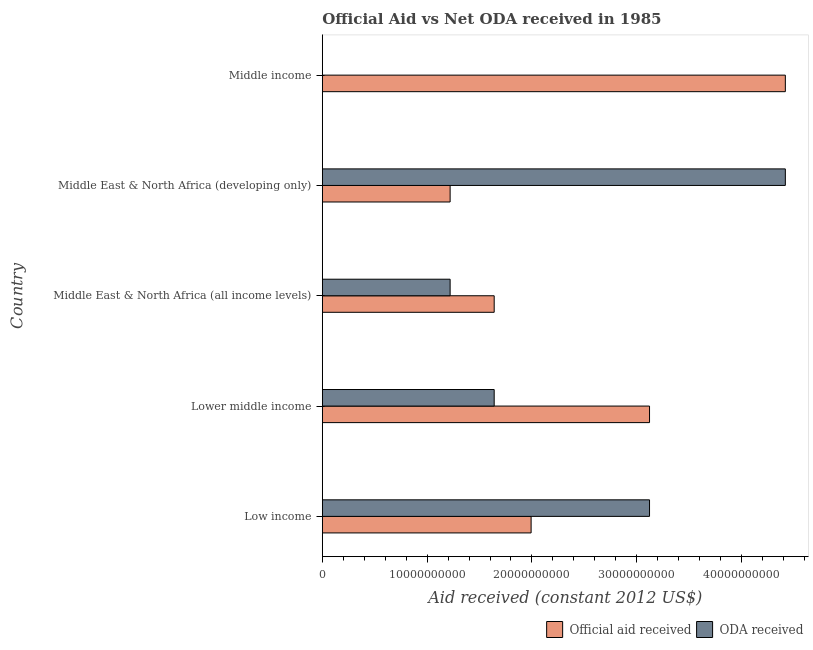How many groups of bars are there?
Offer a terse response. 5. Are the number of bars per tick equal to the number of legend labels?
Make the answer very short. Yes. Are the number of bars on each tick of the Y-axis equal?
Make the answer very short. Yes. What is the official aid received in Middle income?
Keep it short and to the point. 4.42e+1. Across all countries, what is the maximum oda received?
Give a very brief answer. 4.42e+1. Across all countries, what is the minimum oda received?
Make the answer very short. 3.02e+06. In which country was the oda received maximum?
Provide a short and direct response. Middle East & North Africa (developing only). What is the total official aid received in the graph?
Ensure brevity in your answer.  1.24e+11. What is the difference between the official aid received in Lower middle income and that in Middle East & North Africa (all income levels)?
Provide a succinct answer. 1.48e+1. What is the difference between the official aid received in Middle income and the oda received in Lower middle income?
Keep it short and to the point. 2.78e+1. What is the average official aid received per country?
Offer a very short reply. 2.48e+1. What is the difference between the official aid received and oda received in Middle East & North Africa (all income levels)?
Your answer should be compact. 4.20e+09. What is the ratio of the official aid received in Lower middle income to that in Middle East & North Africa (all income levels)?
Give a very brief answer. 1.9. Is the difference between the official aid received in Low income and Middle East & North Africa (all income levels) greater than the difference between the oda received in Low income and Middle East & North Africa (all income levels)?
Offer a terse response. No. What is the difference between the highest and the second highest oda received?
Make the answer very short. 1.30e+1. What is the difference between the highest and the lowest official aid received?
Ensure brevity in your answer.  3.20e+1. Is the sum of the oda received in Lower middle income and Middle income greater than the maximum official aid received across all countries?
Offer a very short reply. No. What does the 1st bar from the top in Middle East & North Africa (developing only) represents?
Provide a succinct answer. ODA received. What does the 1st bar from the bottom in Middle East & North Africa (developing only) represents?
Offer a terse response. Official aid received. What is the difference between two consecutive major ticks on the X-axis?
Your answer should be compact. 1.00e+1. How many legend labels are there?
Keep it short and to the point. 2. How are the legend labels stacked?
Your answer should be compact. Horizontal. What is the title of the graph?
Offer a very short reply. Official Aid vs Net ODA received in 1985 . Does "Exports" appear as one of the legend labels in the graph?
Give a very brief answer. No. What is the label or title of the X-axis?
Your answer should be very brief. Aid received (constant 2012 US$). What is the Aid received (constant 2012 US$) of Official aid received in Low income?
Your answer should be compact. 1.99e+1. What is the Aid received (constant 2012 US$) in ODA received in Low income?
Offer a very short reply. 3.12e+1. What is the Aid received (constant 2012 US$) of Official aid received in Lower middle income?
Your answer should be very brief. 3.12e+1. What is the Aid received (constant 2012 US$) in ODA received in Lower middle income?
Provide a short and direct response. 1.64e+1. What is the Aid received (constant 2012 US$) in Official aid received in Middle East & North Africa (all income levels)?
Your response must be concise. 1.64e+1. What is the Aid received (constant 2012 US$) of ODA received in Middle East & North Africa (all income levels)?
Your answer should be compact. 1.22e+1. What is the Aid received (constant 2012 US$) in Official aid received in Middle East & North Africa (developing only)?
Keep it short and to the point. 1.22e+1. What is the Aid received (constant 2012 US$) in ODA received in Middle East & North Africa (developing only)?
Provide a short and direct response. 4.42e+1. What is the Aid received (constant 2012 US$) of Official aid received in Middle income?
Keep it short and to the point. 4.42e+1. What is the Aid received (constant 2012 US$) in ODA received in Middle income?
Provide a succinct answer. 3.02e+06. Across all countries, what is the maximum Aid received (constant 2012 US$) of Official aid received?
Offer a terse response. 4.42e+1. Across all countries, what is the maximum Aid received (constant 2012 US$) of ODA received?
Your answer should be very brief. 4.42e+1. Across all countries, what is the minimum Aid received (constant 2012 US$) of Official aid received?
Provide a succinct answer. 1.22e+1. Across all countries, what is the minimum Aid received (constant 2012 US$) in ODA received?
Ensure brevity in your answer.  3.02e+06. What is the total Aid received (constant 2012 US$) in Official aid received in the graph?
Ensure brevity in your answer.  1.24e+11. What is the total Aid received (constant 2012 US$) of ODA received in the graph?
Offer a very short reply. 1.04e+11. What is the difference between the Aid received (constant 2012 US$) of Official aid received in Low income and that in Lower middle income?
Offer a very short reply. -1.13e+1. What is the difference between the Aid received (constant 2012 US$) in ODA received in Low income and that in Lower middle income?
Offer a very short reply. 1.48e+1. What is the difference between the Aid received (constant 2012 US$) of Official aid received in Low income and that in Middle East & North Africa (all income levels)?
Offer a terse response. 3.52e+09. What is the difference between the Aid received (constant 2012 US$) of ODA received in Low income and that in Middle East & North Africa (all income levels)?
Provide a succinct answer. 1.90e+1. What is the difference between the Aid received (constant 2012 US$) of Official aid received in Low income and that in Middle East & North Africa (developing only)?
Your answer should be compact. 7.73e+09. What is the difference between the Aid received (constant 2012 US$) in ODA received in Low income and that in Middle East & North Africa (developing only)?
Give a very brief answer. -1.30e+1. What is the difference between the Aid received (constant 2012 US$) of Official aid received in Low income and that in Middle income?
Provide a short and direct response. -2.43e+1. What is the difference between the Aid received (constant 2012 US$) in ODA received in Low income and that in Middle income?
Provide a short and direct response. 3.12e+1. What is the difference between the Aid received (constant 2012 US$) in Official aid received in Lower middle income and that in Middle East & North Africa (all income levels)?
Ensure brevity in your answer.  1.48e+1. What is the difference between the Aid received (constant 2012 US$) of ODA received in Lower middle income and that in Middle East & North Africa (all income levels)?
Provide a succinct answer. 4.20e+09. What is the difference between the Aid received (constant 2012 US$) in Official aid received in Lower middle income and that in Middle East & North Africa (developing only)?
Make the answer very short. 1.90e+1. What is the difference between the Aid received (constant 2012 US$) of ODA received in Lower middle income and that in Middle East & North Africa (developing only)?
Offer a terse response. -2.78e+1. What is the difference between the Aid received (constant 2012 US$) in Official aid received in Lower middle income and that in Middle income?
Make the answer very short. -1.30e+1. What is the difference between the Aid received (constant 2012 US$) of ODA received in Lower middle income and that in Middle income?
Your answer should be very brief. 1.64e+1. What is the difference between the Aid received (constant 2012 US$) of Official aid received in Middle East & North Africa (all income levels) and that in Middle East & North Africa (developing only)?
Give a very brief answer. 4.20e+09. What is the difference between the Aid received (constant 2012 US$) of ODA received in Middle East & North Africa (all income levels) and that in Middle East & North Africa (developing only)?
Make the answer very short. -3.20e+1. What is the difference between the Aid received (constant 2012 US$) in Official aid received in Middle East & North Africa (all income levels) and that in Middle income?
Keep it short and to the point. -2.78e+1. What is the difference between the Aid received (constant 2012 US$) in ODA received in Middle East & North Africa (all income levels) and that in Middle income?
Keep it short and to the point. 1.22e+1. What is the difference between the Aid received (constant 2012 US$) of Official aid received in Middle East & North Africa (developing only) and that in Middle income?
Keep it short and to the point. -3.20e+1. What is the difference between the Aid received (constant 2012 US$) in ODA received in Middle East & North Africa (developing only) and that in Middle income?
Ensure brevity in your answer.  4.42e+1. What is the difference between the Aid received (constant 2012 US$) in Official aid received in Low income and the Aid received (constant 2012 US$) in ODA received in Lower middle income?
Make the answer very short. 3.52e+09. What is the difference between the Aid received (constant 2012 US$) of Official aid received in Low income and the Aid received (constant 2012 US$) of ODA received in Middle East & North Africa (all income levels)?
Provide a succinct answer. 7.73e+09. What is the difference between the Aid received (constant 2012 US$) in Official aid received in Low income and the Aid received (constant 2012 US$) in ODA received in Middle East & North Africa (developing only)?
Provide a succinct answer. -2.43e+1. What is the difference between the Aid received (constant 2012 US$) in Official aid received in Low income and the Aid received (constant 2012 US$) in ODA received in Middle income?
Your response must be concise. 1.99e+1. What is the difference between the Aid received (constant 2012 US$) in Official aid received in Lower middle income and the Aid received (constant 2012 US$) in ODA received in Middle East & North Africa (all income levels)?
Keep it short and to the point. 1.90e+1. What is the difference between the Aid received (constant 2012 US$) of Official aid received in Lower middle income and the Aid received (constant 2012 US$) of ODA received in Middle East & North Africa (developing only)?
Provide a succinct answer. -1.30e+1. What is the difference between the Aid received (constant 2012 US$) of Official aid received in Lower middle income and the Aid received (constant 2012 US$) of ODA received in Middle income?
Your response must be concise. 3.12e+1. What is the difference between the Aid received (constant 2012 US$) in Official aid received in Middle East & North Africa (all income levels) and the Aid received (constant 2012 US$) in ODA received in Middle East & North Africa (developing only)?
Offer a very short reply. -2.78e+1. What is the difference between the Aid received (constant 2012 US$) in Official aid received in Middle East & North Africa (all income levels) and the Aid received (constant 2012 US$) in ODA received in Middle income?
Make the answer very short. 1.64e+1. What is the difference between the Aid received (constant 2012 US$) in Official aid received in Middle East & North Africa (developing only) and the Aid received (constant 2012 US$) in ODA received in Middle income?
Give a very brief answer. 1.22e+1. What is the average Aid received (constant 2012 US$) of Official aid received per country?
Keep it short and to the point. 2.48e+1. What is the average Aid received (constant 2012 US$) in ODA received per country?
Your answer should be compact. 2.08e+1. What is the difference between the Aid received (constant 2012 US$) of Official aid received and Aid received (constant 2012 US$) of ODA received in Low income?
Provide a succinct answer. -1.13e+1. What is the difference between the Aid received (constant 2012 US$) of Official aid received and Aid received (constant 2012 US$) of ODA received in Lower middle income?
Keep it short and to the point. 1.48e+1. What is the difference between the Aid received (constant 2012 US$) of Official aid received and Aid received (constant 2012 US$) of ODA received in Middle East & North Africa (all income levels)?
Give a very brief answer. 4.20e+09. What is the difference between the Aid received (constant 2012 US$) of Official aid received and Aid received (constant 2012 US$) of ODA received in Middle East & North Africa (developing only)?
Provide a succinct answer. -3.20e+1. What is the difference between the Aid received (constant 2012 US$) of Official aid received and Aid received (constant 2012 US$) of ODA received in Middle income?
Your answer should be compact. 4.42e+1. What is the ratio of the Aid received (constant 2012 US$) in Official aid received in Low income to that in Lower middle income?
Provide a short and direct response. 0.64. What is the ratio of the Aid received (constant 2012 US$) in ODA received in Low income to that in Lower middle income?
Provide a succinct answer. 1.9. What is the ratio of the Aid received (constant 2012 US$) in Official aid received in Low income to that in Middle East & North Africa (all income levels)?
Your answer should be very brief. 1.21. What is the ratio of the Aid received (constant 2012 US$) in ODA received in Low income to that in Middle East & North Africa (all income levels)?
Offer a terse response. 2.56. What is the ratio of the Aid received (constant 2012 US$) in Official aid received in Low income to that in Middle East & North Africa (developing only)?
Offer a very short reply. 1.63. What is the ratio of the Aid received (constant 2012 US$) in ODA received in Low income to that in Middle East & North Africa (developing only)?
Offer a terse response. 0.71. What is the ratio of the Aid received (constant 2012 US$) in Official aid received in Low income to that in Middle income?
Your answer should be compact. 0.45. What is the ratio of the Aid received (constant 2012 US$) of ODA received in Low income to that in Middle income?
Give a very brief answer. 1.03e+04. What is the ratio of the Aid received (constant 2012 US$) of Official aid received in Lower middle income to that in Middle East & North Africa (all income levels)?
Give a very brief answer. 1.9. What is the ratio of the Aid received (constant 2012 US$) in ODA received in Lower middle income to that in Middle East & North Africa (all income levels)?
Your response must be concise. 1.34. What is the ratio of the Aid received (constant 2012 US$) in Official aid received in Lower middle income to that in Middle East & North Africa (developing only)?
Make the answer very short. 2.56. What is the ratio of the Aid received (constant 2012 US$) of ODA received in Lower middle income to that in Middle East & North Africa (developing only)?
Provide a succinct answer. 0.37. What is the ratio of the Aid received (constant 2012 US$) in Official aid received in Lower middle income to that in Middle income?
Your response must be concise. 0.71. What is the ratio of the Aid received (constant 2012 US$) in ODA received in Lower middle income to that in Middle income?
Offer a terse response. 5429.81. What is the ratio of the Aid received (constant 2012 US$) of Official aid received in Middle East & North Africa (all income levels) to that in Middle East & North Africa (developing only)?
Your answer should be very brief. 1.34. What is the ratio of the Aid received (constant 2012 US$) of ODA received in Middle East & North Africa (all income levels) to that in Middle East & North Africa (developing only)?
Your response must be concise. 0.28. What is the ratio of the Aid received (constant 2012 US$) in Official aid received in Middle East & North Africa (all income levels) to that in Middle income?
Your answer should be very brief. 0.37. What is the ratio of the Aid received (constant 2012 US$) in ODA received in Middle East & North Africa (all income levels) to that in Middle income?
Offer a very short reply. 4037.72. What is the ratio of the Aid received (constant 2012 US$) of Official aid received in Middle East & North Africa (developing only) to that in Middle income?
Provide a short and direct response. 0.28. What is the ratio of the Aid received (constant 2012 US$) of ODA received in Middle East & North Africa (developing only) to that in Middle income?
Your response must be concise. 1.46e+04. What is the difference between the highest and the second highest Aid received (constant 2012 US$) of Official aid received?
Provide a short and direct response. 1.30e+1. What is the difference between the highest and the second highest Aid received (constant 2012 US$) of ODA received?
Make the answer very short. 1.30e+1. What is the difference between the highest and the lowest Aid received (constant 2012 US$) in Official aid received?
Provide a succinct answer. 3.20e+1. What is the difference between the highest and the lowest Aid received (constant 2012 US$) of ODA received?
Offer a terse response. 4.42e+1. 